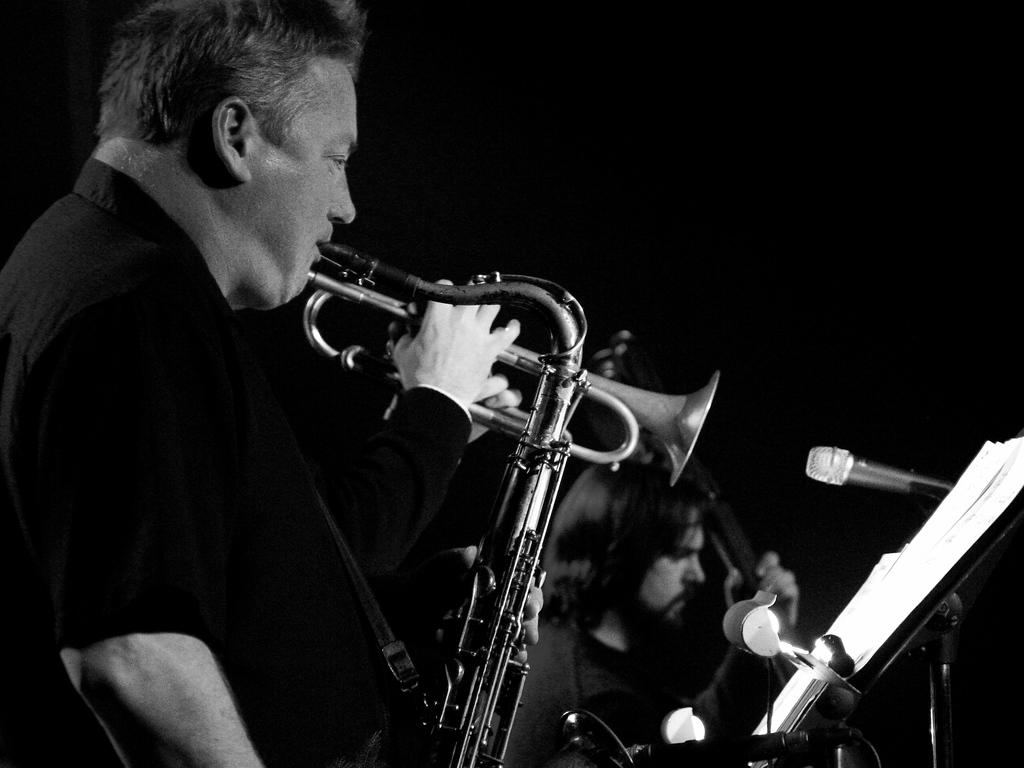What type of picture is in the image? The image contains a black and white picture. Who or what is depicted in the picture? There are people in the picture. What are the people wearing? The people are wearing clothes. What objects are associated with the people in the picture? There are musical instruments and microphones in the picture. What might the people be using the papers for? The people might be using the papers for notes or lyrics. What type of battle is taking place in the image? There is no battle present in the image; it contains a picture of people with musical instruments and microphones. Where is the class being held in the image? There is no class present in the image; it contains a picture of people with musical instruments and microphones. 